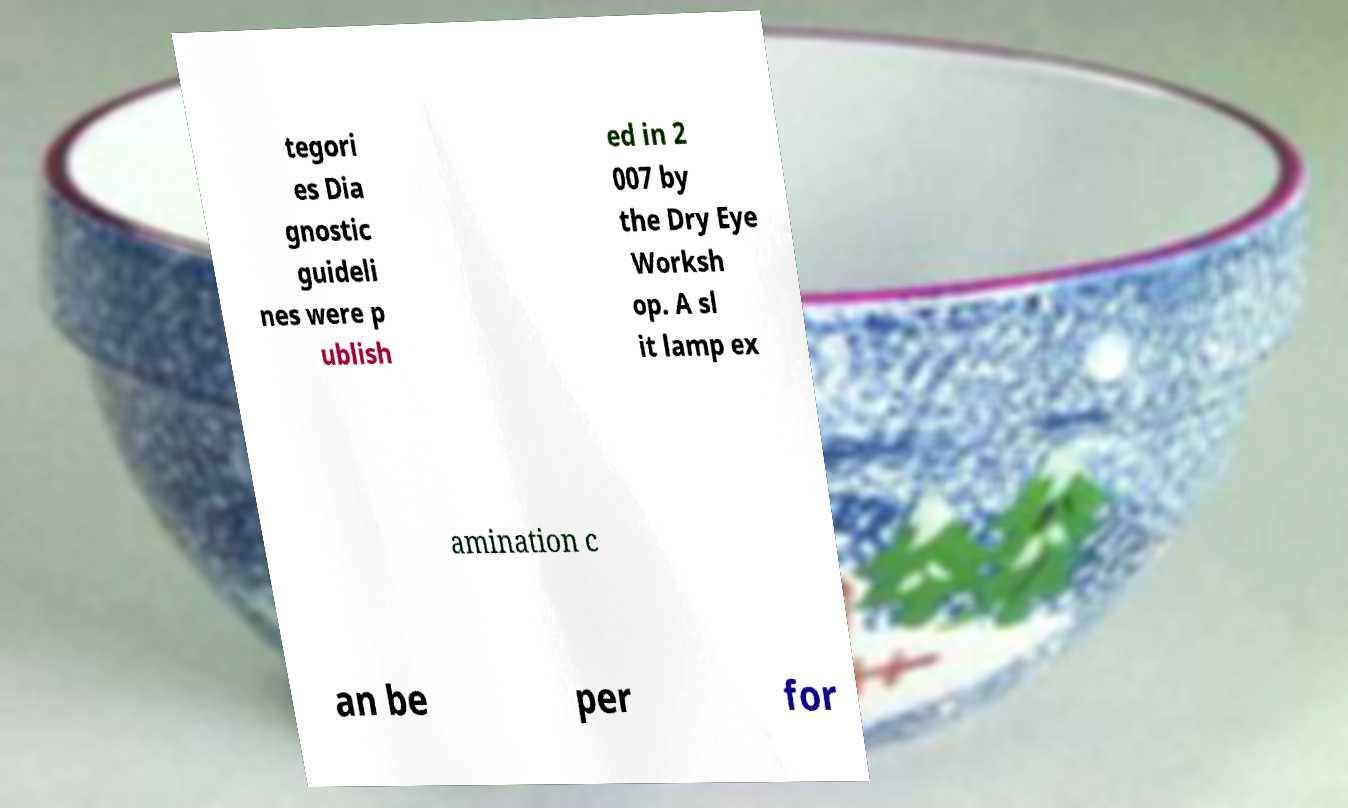What messages or text are displayed in this image? I need them in a readable, typed format. tegori es Dia gnostic guideli nes were p ublish ed in 2 007 by the Dry Eye Worksh op. A sl it lamp ex amination c an be per for 